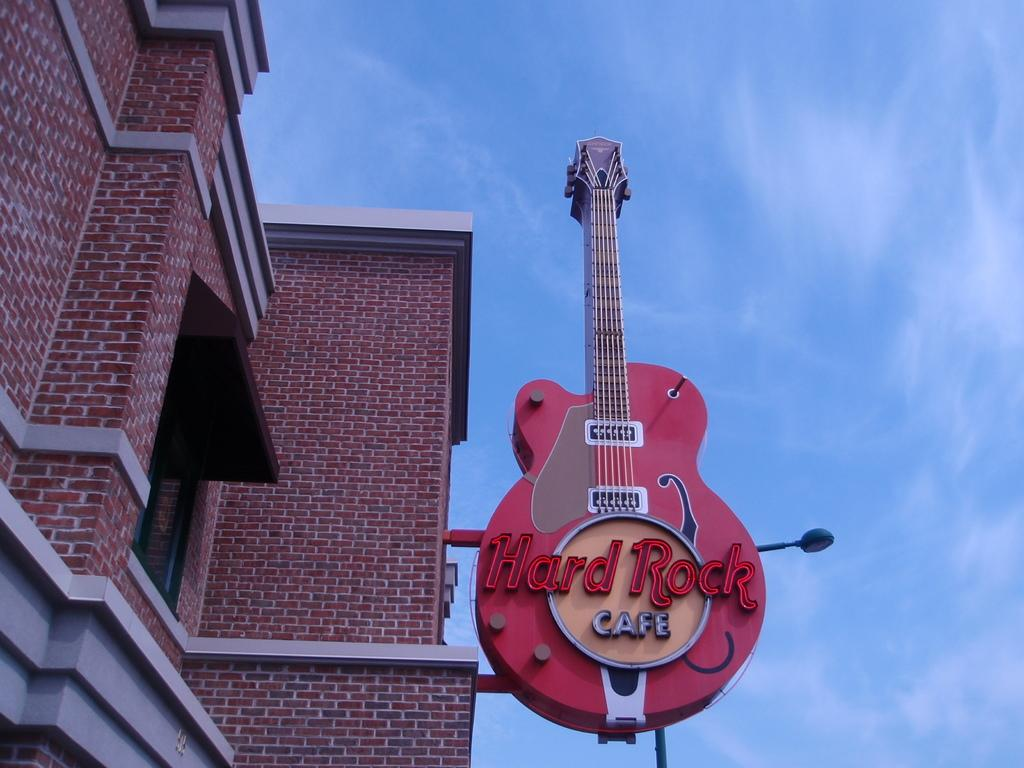What structure is located on the left side of the image? There is a building on the left side of the image. What is the color and material of the building's walls? The building has red brick walls. What feature can be seen on the building? The building has a window. What musical instrument is present in the image? There is a guitar in the image. What type of lighting is present in the image? There is a lamp in the image. What is visible at the top of the image? The sky is visible at the top of the image. What type of substance is dripping from the ring in the image? There is no ring present in the image, so it is not possible to answer that question. 